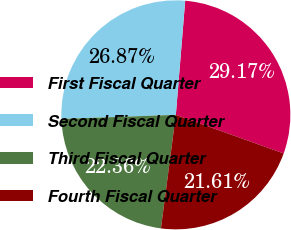Convert chart. <chart><loc_0><loc_0><loc_500><loc_500><pie_chart><fcel>First Fiscal Quarter<fcel>Second Fiscal Quarter<fcel>Third Fiscal Quarter<fcel>Fourth Fiscal Quarter<nl><fcel>29.17%<fcel>26.87%<fcel>22.36%<fcel>21.61%<nl></chart> 